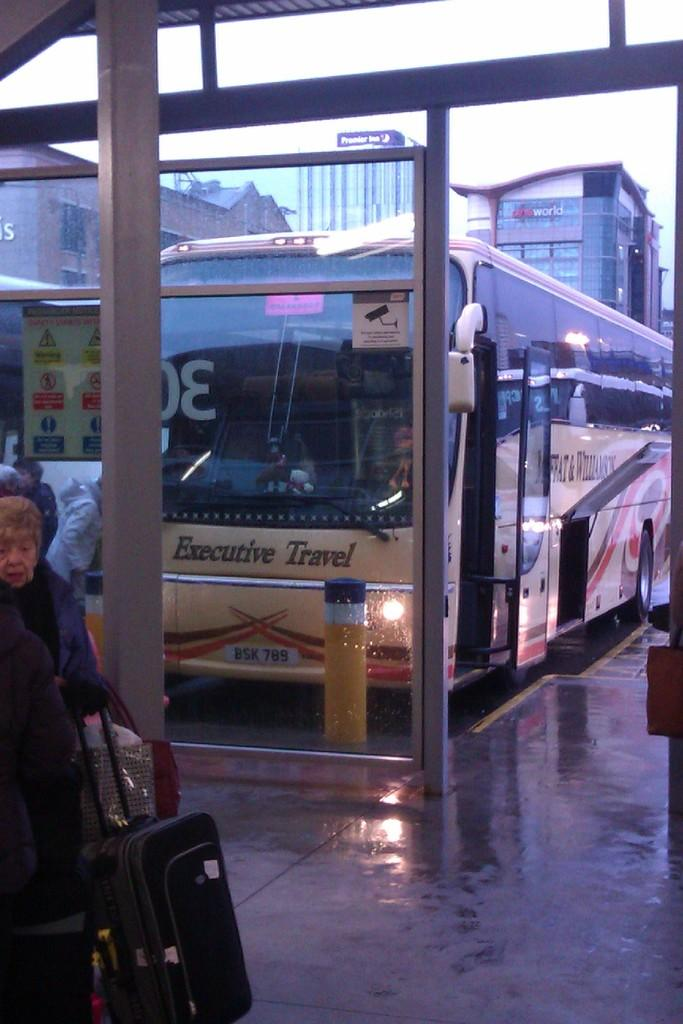What is the main subject of the image? The main subject of the image is a bus. Where is the bus located in relation to other objects in the image? The bus is in front of a pole. What can be seen in the background of the image? There are buildings in the background of the image. What are some people doing near the bus? Some people are walking with trolleys in front of the bus. How many legs does the bus have in the image? Buses do not have legs; they have wheels. In the image, the bus has four wheels. What type of dust can be seen on the selection of trolleys in the image? There is no dust visible on the trolleys in the image, and there is no selection of trolleys mentioned in the facts. 